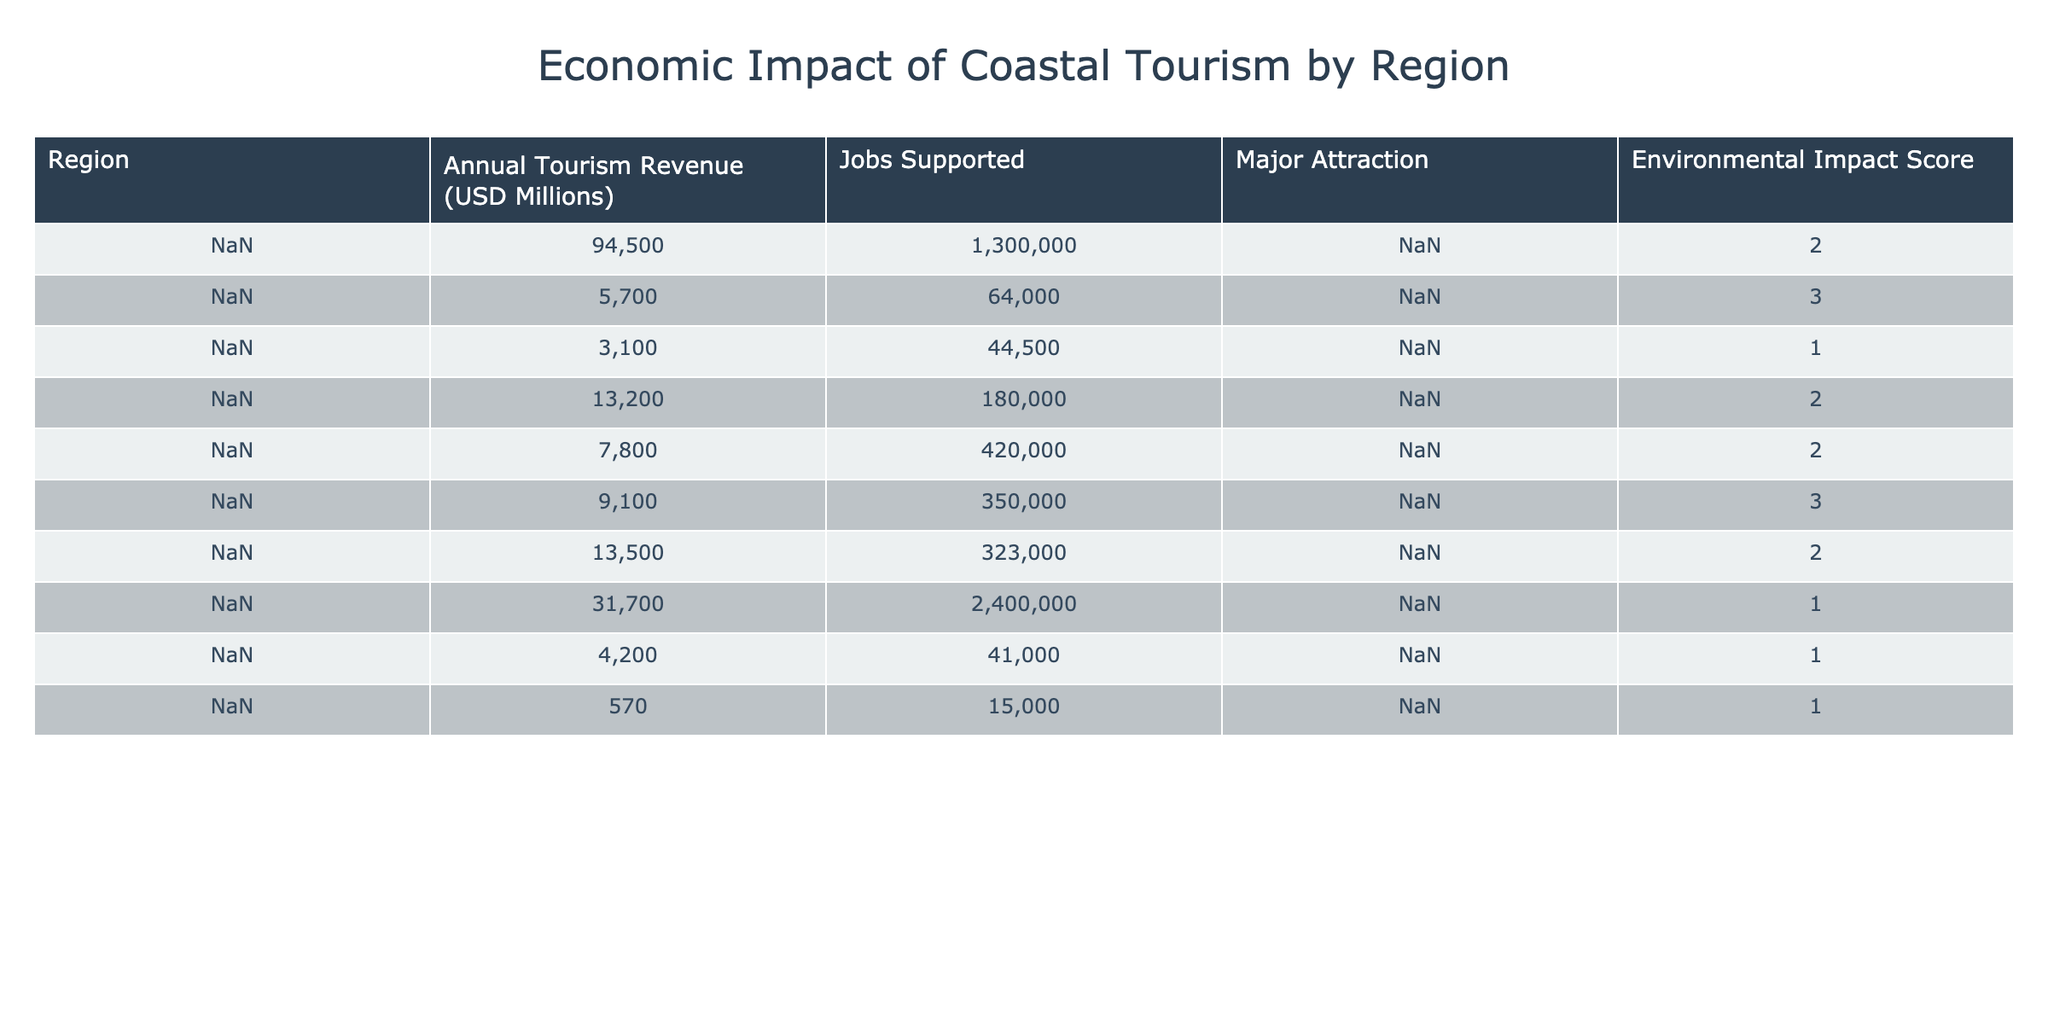What region has the highest annual tourism revenue? The region with the highest annual tourism revenue is Florida, which reports an amount of 94,500 million USD.
Answer: Florida How many jobs are supported by the Caribbean Islands' tourism? The Caribbean Islands support 2,400,000 jobs according to the table.
Answer: 2,400,000 Which region has the lowest environmental impact score? The region with the lowest environmental impact score is Seychelles, having a score of 1.
Answer: Seychelles What is the combined annual tourism revenue of the Maldives and Gold Coast (Australia)? The annual tourism revenue of the Maldives is 3,100 million USD and the Gold Coast (Australia) is 4,200 million USD. Adding them together gives 3,100 + 4,200 = 7,300 million USD.
Answer: 7,300 million USD Which region supports the maximum number of jobs and what is that number? The region supporting the maximum number of jobs is the Caribbean Islands, with 2,400,000 jobs.
Answer: 2,400,000 What is the average annual tourism revenue for regions with an environmental impact score of 1? The regions with an environmental impact score of 1 are the Maldives, Caribbean Islands, Gold Coast (Australia), and Seychelles, with revenues of 3,100, 31,700, 4,200, and 570 million USD respectively. Their total revenue is 3,100 + 31,700 + 4,200 + 570 = 39,570 million USD. The average is 39,570 / 4 = 9,892.5 million USD.
Answer: 9,892.5 million USD Are there any regions with an environmental impact score of 3 that support more than 100,000 jobs? There are two regions, the Great Barrier Reef and Cancun, with environmental impact scores of 3, but only Cancun supports over 100,000 jobs (350,000 jobs), while the Great Barrier Reef supports 64,000 jobs. Therefore, the answer is yes.
Answer: Yes How many more jobs are supported by Phuket compared to Seychelles? Phuket supports 323,000 jobs while Seychelles supports 15,000 jobs. The difference in jobs is 323,000 - 15,000 = 308,000 jobs.
Answer: 308,000 jobs What percentage of jobs supported by the Caribbean Islands does Cancun support? The Caribbean Islands support 2,400,000 jobs and Cancun supports 350,000 jobs. To find the percentage, we use the formula (350,000 / 2,400,000) * 100, which gives approximately 14.58%.
Answer: 14.58% What is the total annual tourism revenue for regions with an environmental impact score of 2? The regions with an environmental impact score of 2 are Florida, Costa del Sol, Bali, and Phuket with revenues of 94,500, 13,200, 7,800, and 13,500 million USD respectively. The total is 94,500 + 13,200 + 7,800 + 13,500 = 129,000 million USD.
Answer: 129,000 million USD 